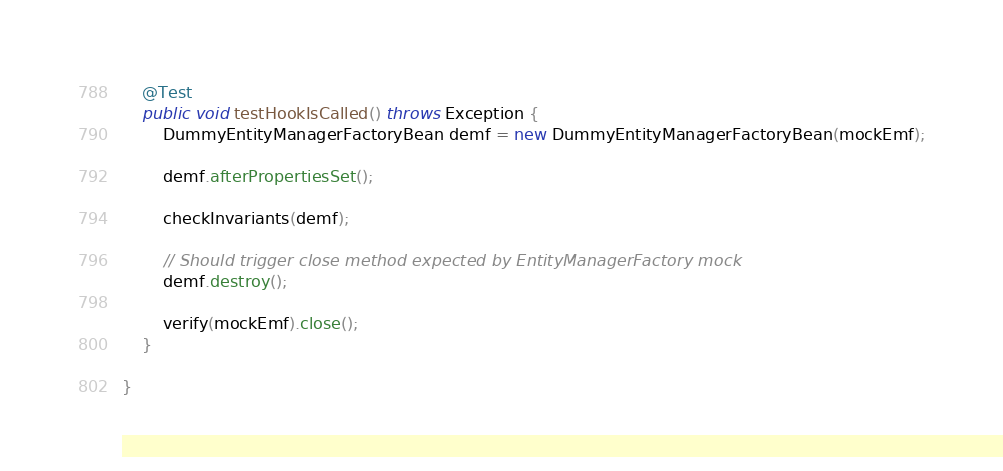<code> <loc_0><loc_0><loc_500><loc_500><_Java_>	@Test
	public void testHookIsCalled() throws Exception {
		DummyEntityManagerFactoryBean demf = new DummyEntityManagerFactoryBean(mockEmf);

		demf.afterPropertiesSet();

		checkInvariants(demf);

		// Should trigger close method expected by EntityManagerFactory mock
		demf.destroy();

		verify(mockEmf).close();
	}

}
</code> 